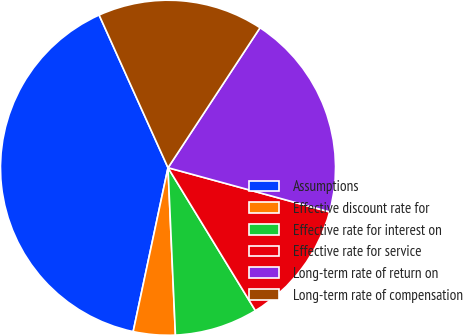Convert chart. <chart><loc_0><loc_0><loc_500><loc_500><pie_chart><fcel>Assumptions<fcel>Effective discount rate for<fcel>Effective rate for interest on<fcel>Effective rate for service<fcel>Long-term rate of return on<fcel>Long-term rate of compensation<nl><fcel>39.92%<fcel>4.04%<fcel>8.03%<fcel>12.02%<fcel>19.99%<fcel>16.0%<nl></chart> 